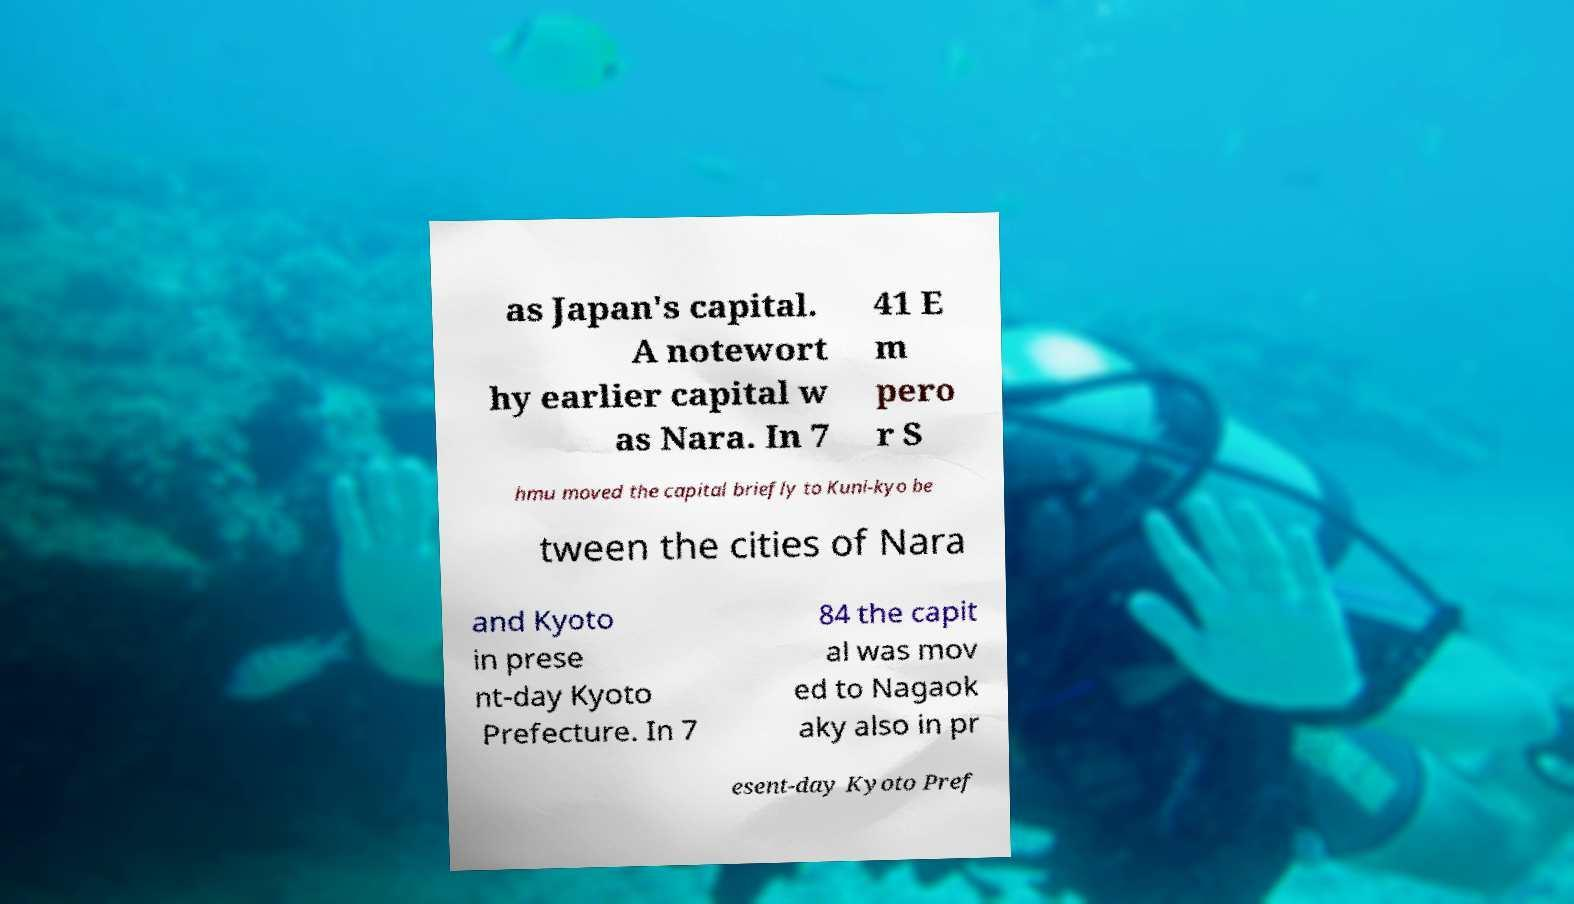Could you assist in decoding the text presented in this image and type it out clearly? as Japan's capital. A notewort hy earlier capital w as Nara. In 7 41 E m pero r S hmu moved the capital briefly to Kuni-kyo be tween the cities of Nara and Kyoto in prese nt-day Kyoto Prefecture. In 7 84 the capit al was mov ed to Nagaok aky also in pr esent-day Kyoto Pref 